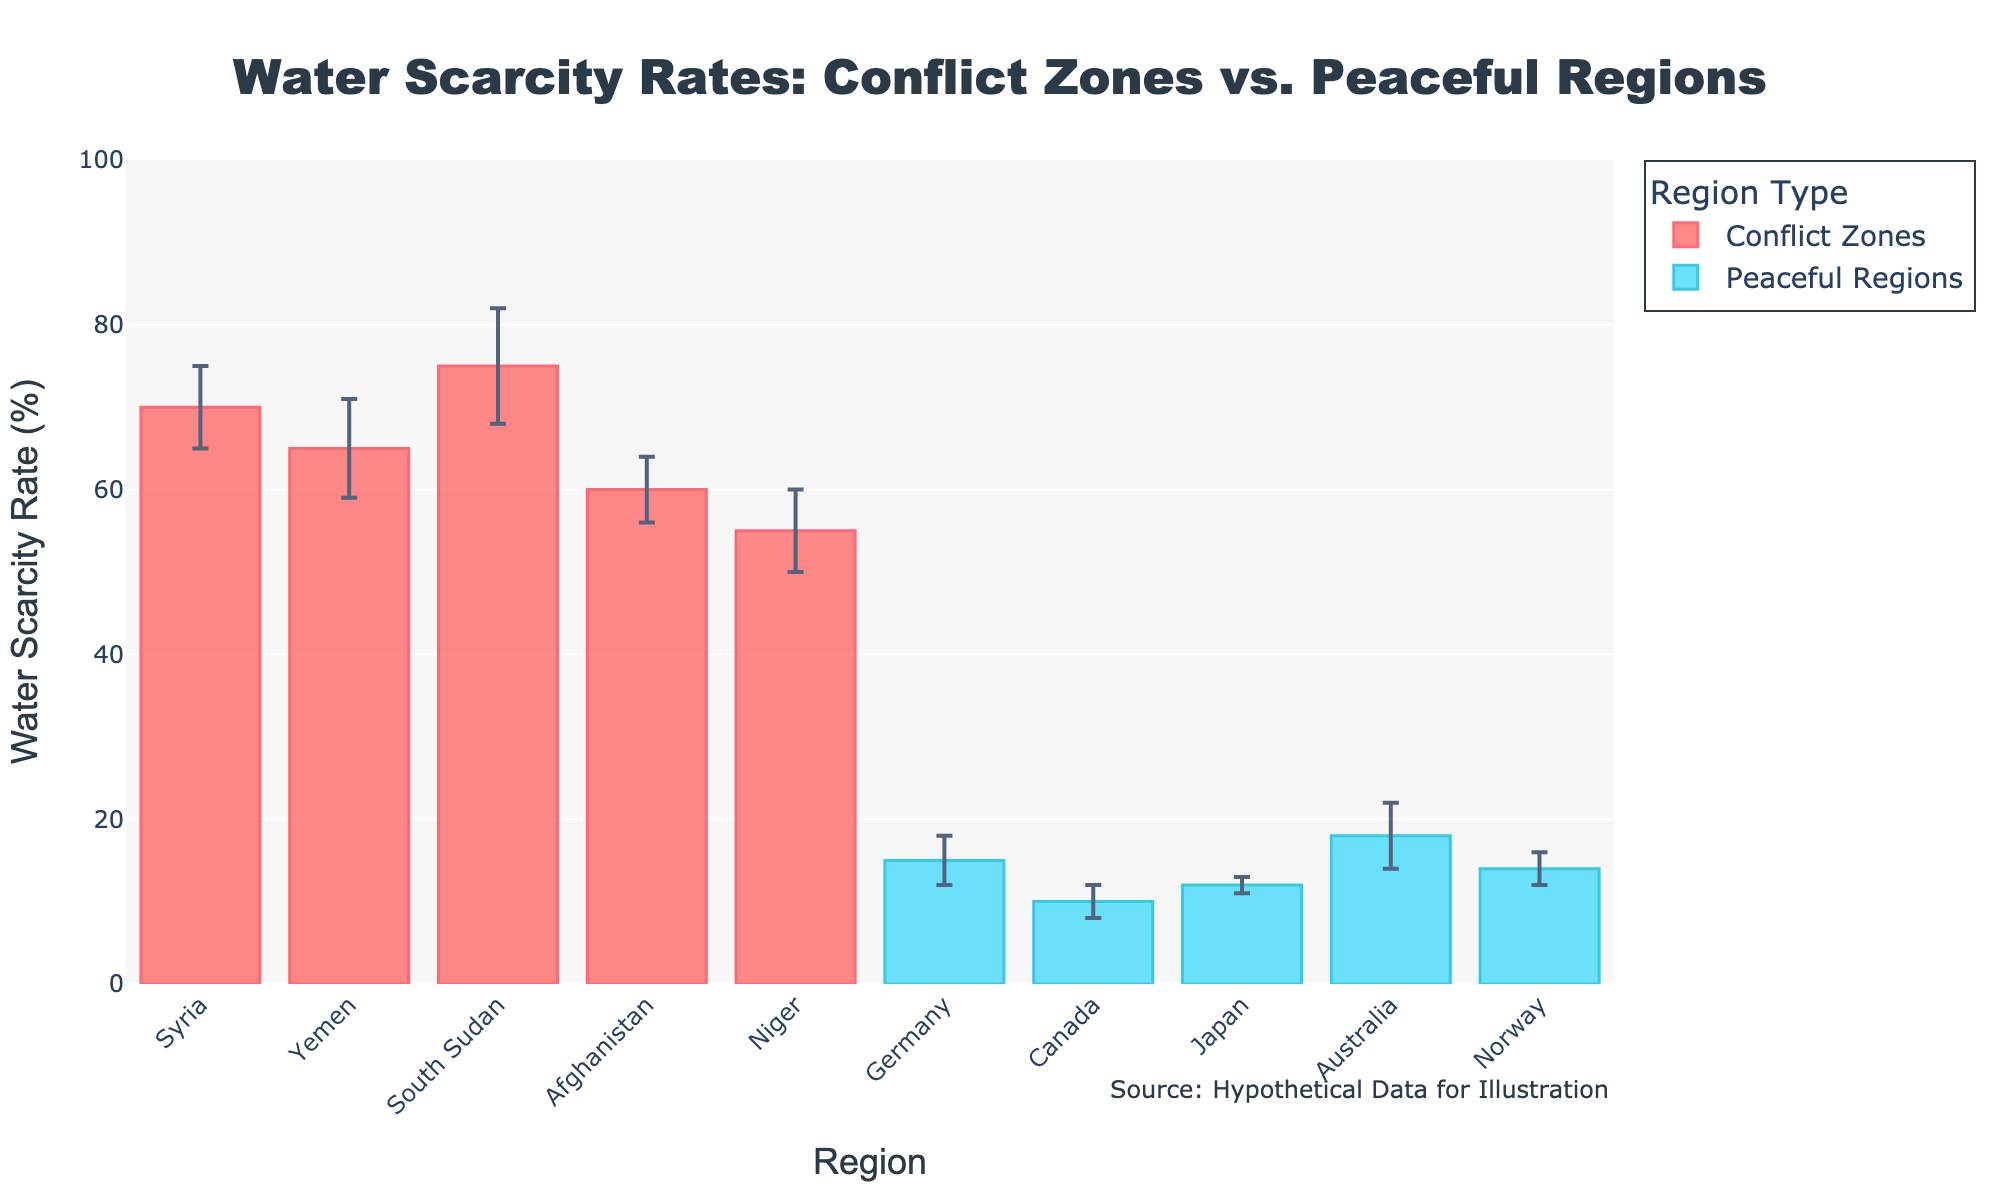How many regions are represented in the plot? Count the number of data points (bars) in the plot to identify the total number of regions. Conflict zones have 5 regions, and peaceful regions have 5 regions.
Answer: 10 What is the title of the plot? Read the title text located at the top of the plot. It is typically larger and more prominent than other texts.
Answer: Water Scarcity Rates: Conflict Zones vs. Peaceful Regions Which conflict zone has the highest water scarcity rate and what is the rate? Look at the bars colored for conflict zones and identify the tallest bar. The tallest bar represents South Sudan with a rate of 75%.
Answer: South Sudan, 75% What is the average water scarcity rate for peaceful regions? Add up the water scarcity rates for all peaceful regions and divide by the number of peaceful regions. (15+10+12+18+14)/5 = 69/5 = 13.8%
Answer: 13.8% Which peaceful region has the lowest water scarcity rate and by how much does it differ from the highest rate in peaceful regions? Identify the smallest bar for peaceful regions (Canada, 10%) and the tallest bar for peaceful regions (Australia, 18%). Subtract the smallest rate from the highest rate: 18 - 10 = 8%.
Answer: Canada, 8% How does the average water scarcity rate of conflict zones compare to peaceful regions? Calculate the average rate for conflict zones: (70+65+75+60+55)/5 = 325/5 = 65%. Compare this to the previously calculated average for peaceful regions (13.8%). 65% (Conflict Zones) is much higher than 13.8% (Peaceful Regions).
Answer: 65% (Conflict Zones) is much higher than 13.8% (Peaceful Regions) What's the difference between the highest and the lowest water scarcity rates in conflict zones? Identify the highest (South Sudan, 75%) and lowest (Niger, 55%) water scarcity rates among conflict zones. Subtract the lowest rate from the highest rate: 75 - 55 = 20%.
Answer: 20% Which region has the smallest error interval, and what is the interval's value? Identify the region with the smallest numerical error interval by examining the error bars. The smallest interval is for Japan (1%).
Answer: Japan, 1% What is the total range of water scarcity rates shown in the plot? Identify the maximum rate (South Sudan, 75%) and minimum rate (Canada, 10%) across both region types. Subtract the smallest rate from the highest rate: 75 - 10 = 65%
Answer: 65% 